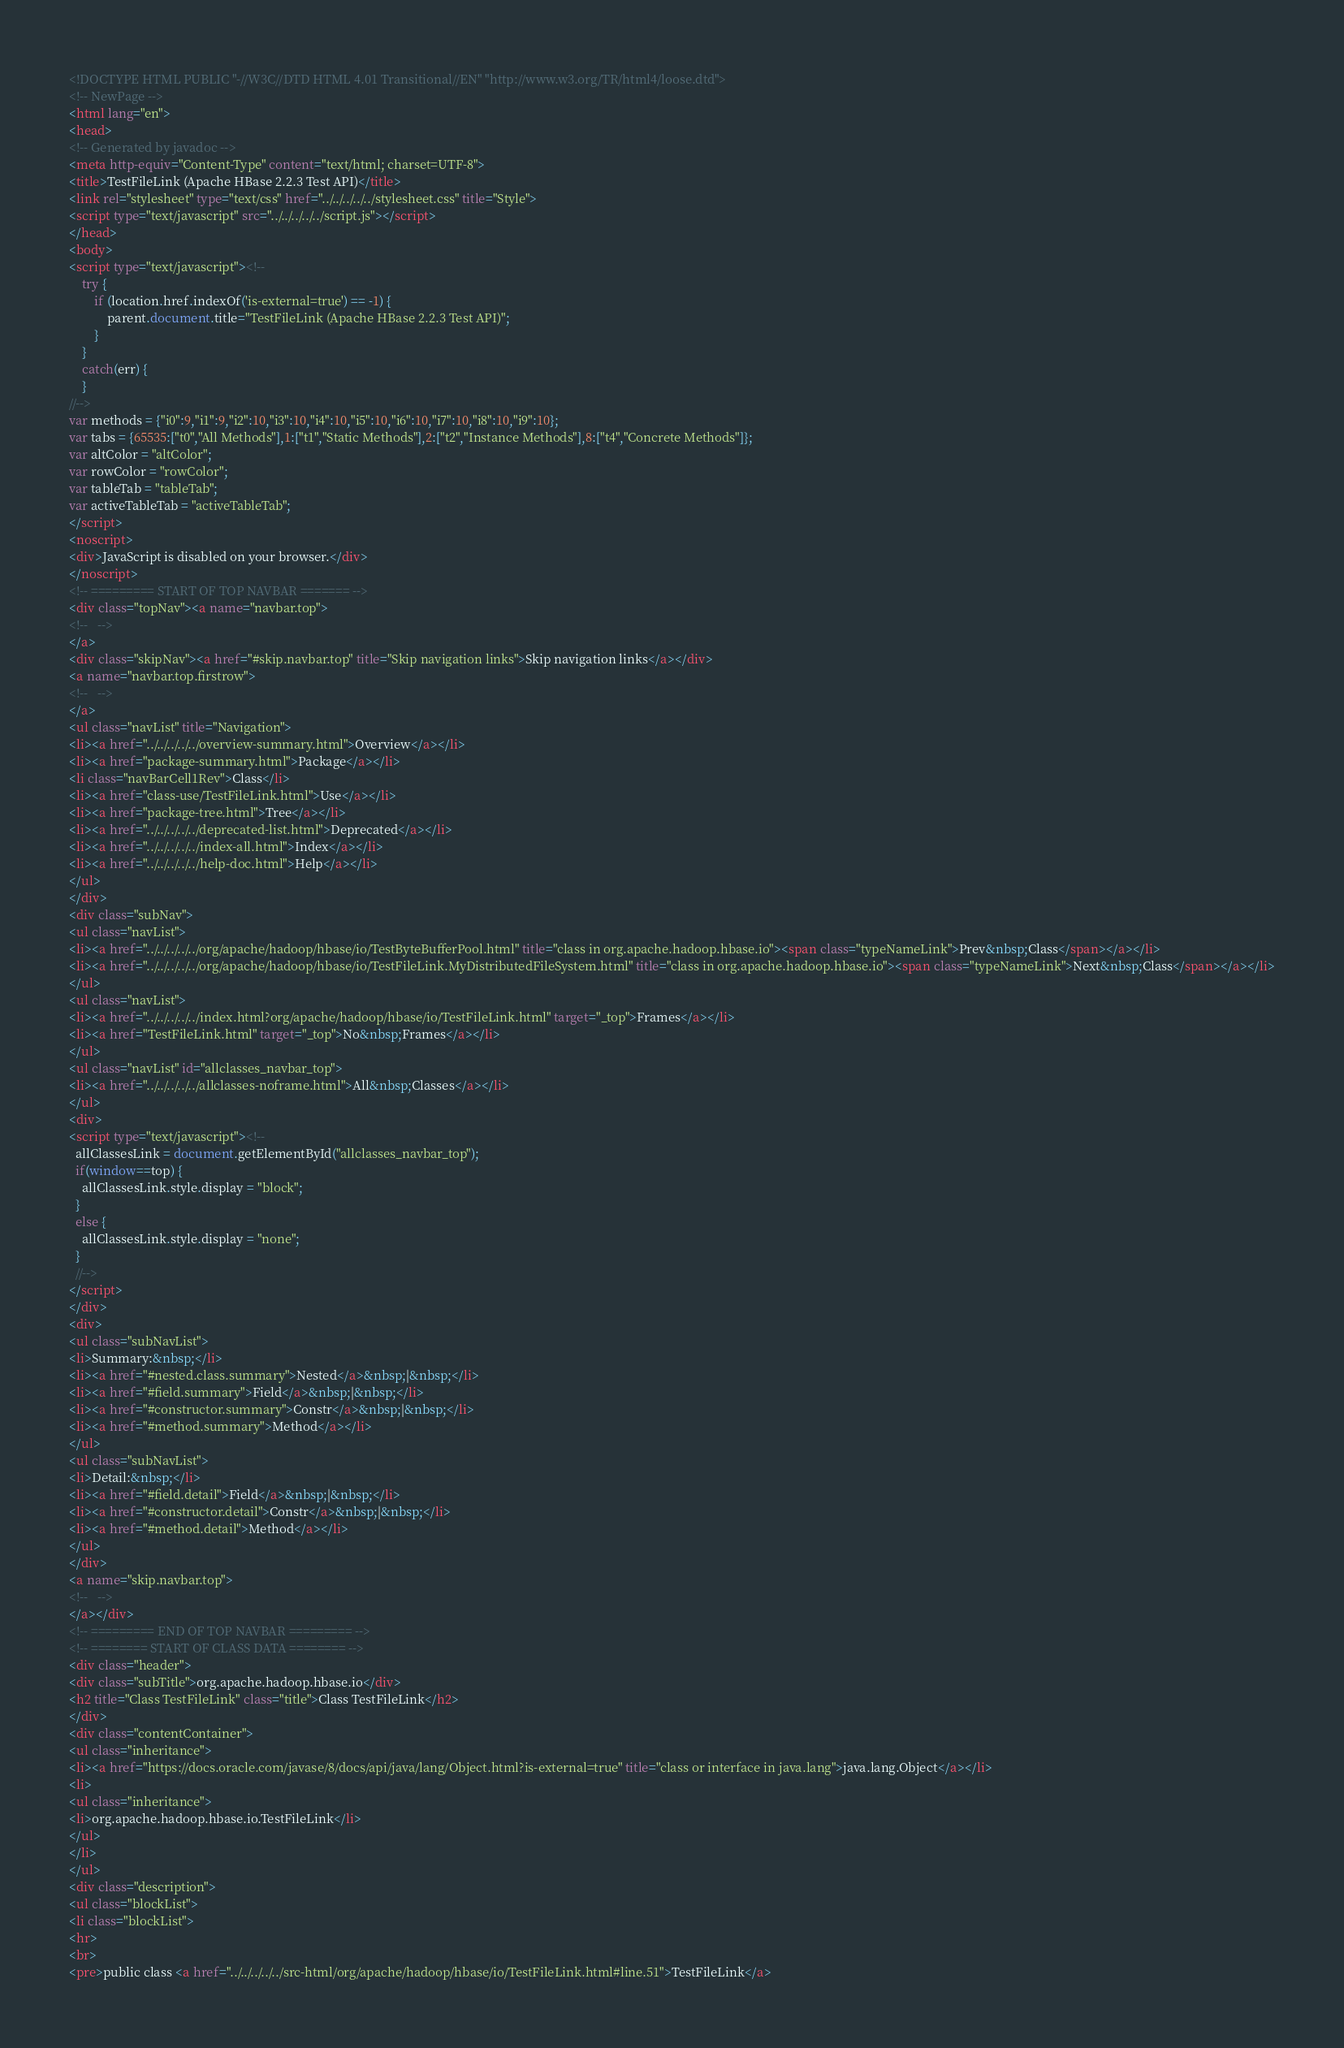<code> <loc_0><loc_0><loc_500><loc_500><_HTML_><!DOCTYPE HTML PUBLIC "-//W3C//DTD HTML 4.01 Transitional//EN" "http://www.w3.org/TR/html4/loose.dtd">
<!-- NewPage -->
<html lang="en">
<head>
<!-- Generated by javadoc -->
<meta http-equiv="Content-Type" content="text/html; charset=UTF-8">
<title>TestFileLink (Apache HBase 2.2.3 Test API)</title>
<link rel="stylesheet" type="text/css" href="../../../../../stylesheet.css" title="Style">
<script type="text/javascript" src="../../../../../script.js"></script>
</head>
<body>
<script type="text/javascript"><!--
    try {
        if (location.href.indexOf('is-external=true') == -1) {
            parent.document.title="TestFileLink (Apache HBase 2.2.3 Test API)";
        }
    }
    catch(err) {
    }
//-->
var methods = {"i0":9,"i1":9,"i2":10,"i3":10,"i4":10,"i5":10,"i6":10,"i7":10,"i8":10,"i9":10};
var tabs = {65535:["t0","All Methods"],1:["t1","Static Methods"],2:["t2","Instance Methods"],8:["t4","Concrete Methods"]};
var altColor = "altColor";
var rowColor = "rowColor";
var tableTab = "tableTab";
var activeTableTab = "activeTableTab";
</script>
<noscript>
<div>JavaScript is disabled on your browser.</div>
</noscript>
<!-- ========= START OF TOP NAVBAR ======= -->
<div class="topNav"><a name="navbar.top">
<!--   -->
</a>
<div class="skipNav"><a href="#skip.navbar.top" title="Skip navigation links">Skip navigation links</a></div>
<a name="navbar.top.firstrow">
<!--   -->
</a>
<ul class="navList" title="Navigation">
<li><a href="../../../../../overview-summary.html">Overview</a></li>
<li><a href="package-summary.html">Package</a></li>
<li class="navBarCell1Rev">Class</li>
<li><a href="class-use/TestFileLink.html">Use</a></li>
<li><a href="package-tree.html">Tree</a></li>
<li><a href="../../../../../deprecated-list.html">Deprecated</a></li>
<li><a href="../../../../../index-all.html">Index</a></li>
<li><a href="../../../../../help-doc.html">Help</a></li>
</ul>
</div>
<div class="subNav">
<ul class="navList">
<li><a href="../../../../../org/apache/hadoop/hbase/io/TestByteBufferPool.html" title="class in org.apache.hadoop.hbase.io"><span class="typeNameLink">Prev&nbsp;Class</span></a></li>
<li><a href="../../../../../org/apache/hadoop/hbase/io/TestFileLink.MyDistributedFileSystem.html" title="class in org.apache.hadoop.hbase.io"><span class="typeNameLink">Next&nbsp;Class</span></a></li>
</ul>
<ul class="navList">
<li><a href="../../../../../index.html?org/apache/hadoop/hbase/io/TestFileLink.html" target="_top">Frames</a></li>
<li><a href="TestFileLink.html" target="_top">No&nbsp;Frames</a></li>
</ul>
<ul class="navList" id="allclasses_navbar_top">
<li><a href="../../../../../allclasses-noframe.html">All&nbsp;Classes</a></li>
</ul>
<div>
<script type="text/javascript"><!--
  allClassesLink = document.getElementById("allclasses_navbar_top");
  if(window==top) {
    allClassesLink.style.display = "block";
  }
  else {
    allClassesLink.style.display = "none";
  }
  //-->
</script>
</div>
<div>
<ul class="subNavList">
<li>Summary:&nbsp;</li>
<li><a href="#nested.class.summary">Nested</a>&nbsp;|&nbsp;</li>
<li><a href="#field.summary">Field</a>&nbsp;|&nbsp;</li>
<li><a href="#constructor.summary">Constr</a>&nbsp;|&nbsp;</li>
<li><a href="#method.summary">Method</a></li>
</ul>
<ul class="subNavList">
<li>Detail:&nbsp;</li>
<li><a href="#field.detail">Field</a>&nbsp;|&nbsp;</li>
<li><a href="#constructor.detail">Constr</a>&nbsp;|&nbsp;</li>
<li><a href="#method.detail">Method</a></li>
</ul>
</div>
<a name="skip.navbar.top">
<!--   -->
</a></div>
<!-- ========= END OF TOP NAVBAR ========= -->
<!-- ======== START OF CLASS DATA ======== -->
<div class="header">
<div class="subTitle">org.apache.hadoop.hbase.io</div>
<h2 title="Class TestFileLink" class="title">Class TestFileLink</h2>
</div>
<div class="contentContainer">
<ul class="inheritance">
<li><a href="https://docs.oracle.com/javase/8/docs/api/java/lang/Object.html?is-external=true" title="class or interface in java.lang">java.lang.Object</a></li>
<li>
<ul class="inheritance">
<li>org.apache.hadoop.hbase.io.TestFileLink</li>
</ul>
</li>
</ul>
<div class="description">
<ul class="blockList">
<li class="blockList">
<hr>
<br>
<pre>public class <a href="../../../../../src-html/org/apache/hadoop/hbase/io/TestFileLink.html#line.51">TestFileLink</a></code> 